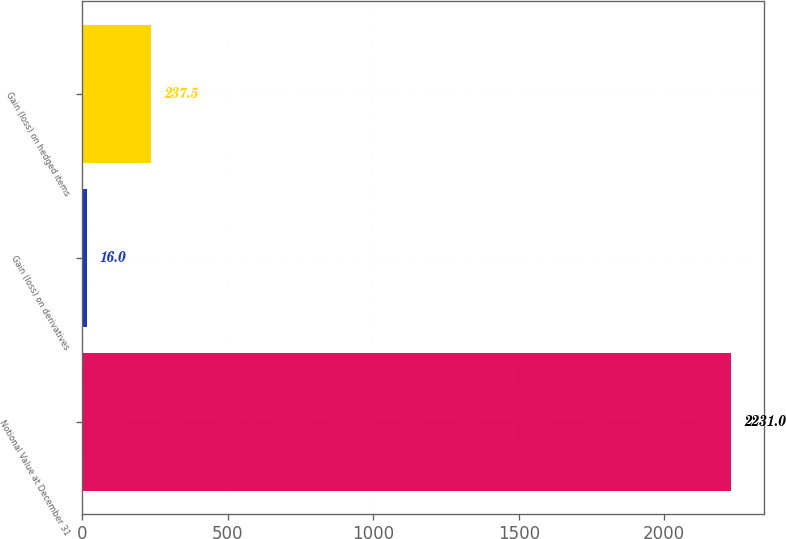<chart> <loc_0><loc_0><loc_500><loc_500><bar_chart><fcel>Notional Value at December 31<fcel>Gain (loss) on derivatives<fcel>Gain (loss) on hedged items<nl><fcel>2231<fcel>16<fcel>237.5<nl></chart> 